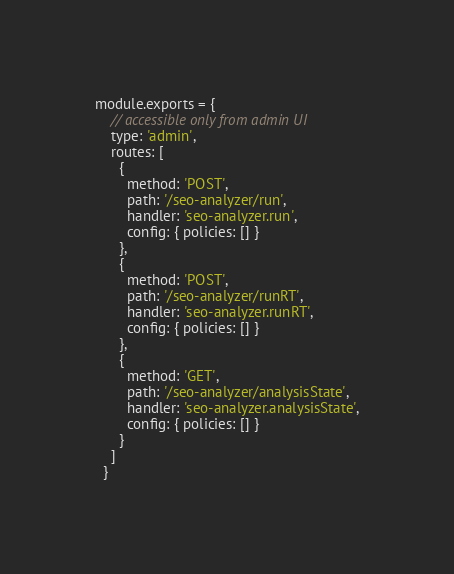<code> <loc_0><loc_0><loc_500><loc_500><_JavaScript_>module.exports = {
    // accessible only from admin UI
    type: 'admin',
    routes: [
      {
        method: 'POST',
        path: '/seo-analyzer/run',
        handler: 'seo-analyzer.run',
        config: { policies: [] }
      },
      {
        method: 'POST',
        path: '/seo-analyzer/runRT',
        handler: 'seo-analyzer.runRT',
        config: { policies: [] }
      },
      {
        method: 'GET',
        path: '/seo-analyzer/analysisState',
        handler: 'seo-analyzer.analysisState',
        config: { policies: [] }
      }
    ]
  }</code> 